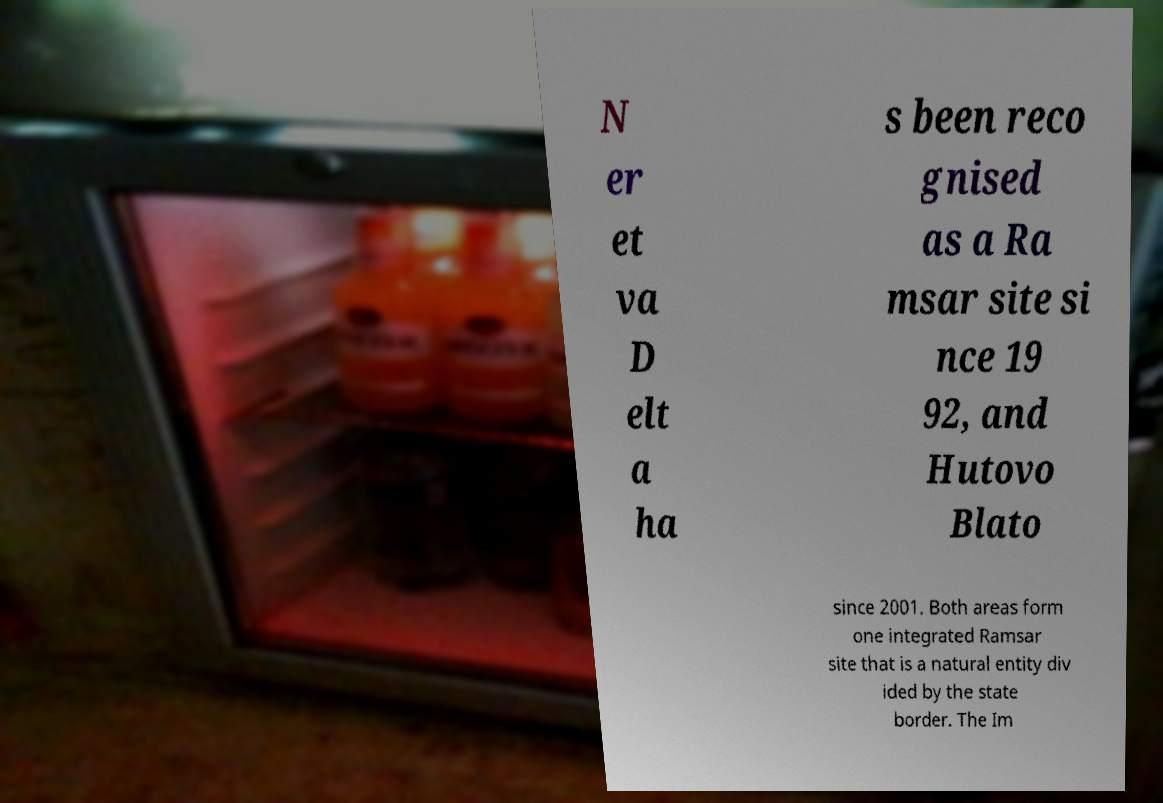Could you extract and type out the text from this image? N er et va D elt a ha s been reco gnised as a Ra msar site si nce 19 92, and Hutovo Blato since 2001. Both areas form one integrated Ramsar site that is a natural entity div ided by the state border. The Im 